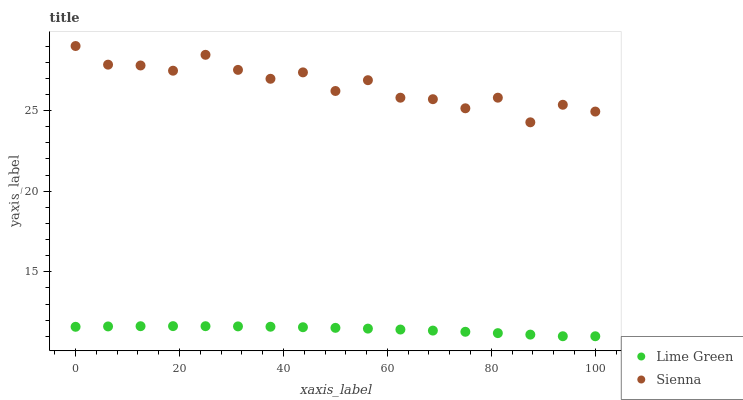Does Lime Green have the minimum area under the curve?
Answer yes or no. Yes. Does Sienna have the maximum area under the curve?
Answer yes or no. Yes. Does Lime Green have the maximum area under the curve?
Answer yes or no. No. Is Lime Green the smoothest?
Answer yes or no. Yes. Is Sienna the roughest?
Answer yes or no. Yes. Is Lime Green the roughest?
Answer yes or no. No. Does Lime Green have the lowest value?
Answer yes or no. Yes. Does Sienna have the highest value?
Answer yes or no. Yes. Does Lime Green have the highest value?
Answer yes or no. No. Is Lime Green less than Sienna?
Answer yes or no. Yes. Is Sienna greater than Lime Green?
Answer yes or no. Yes. Does Lime Green intersect Sienna?
Answer yes or no. No. 